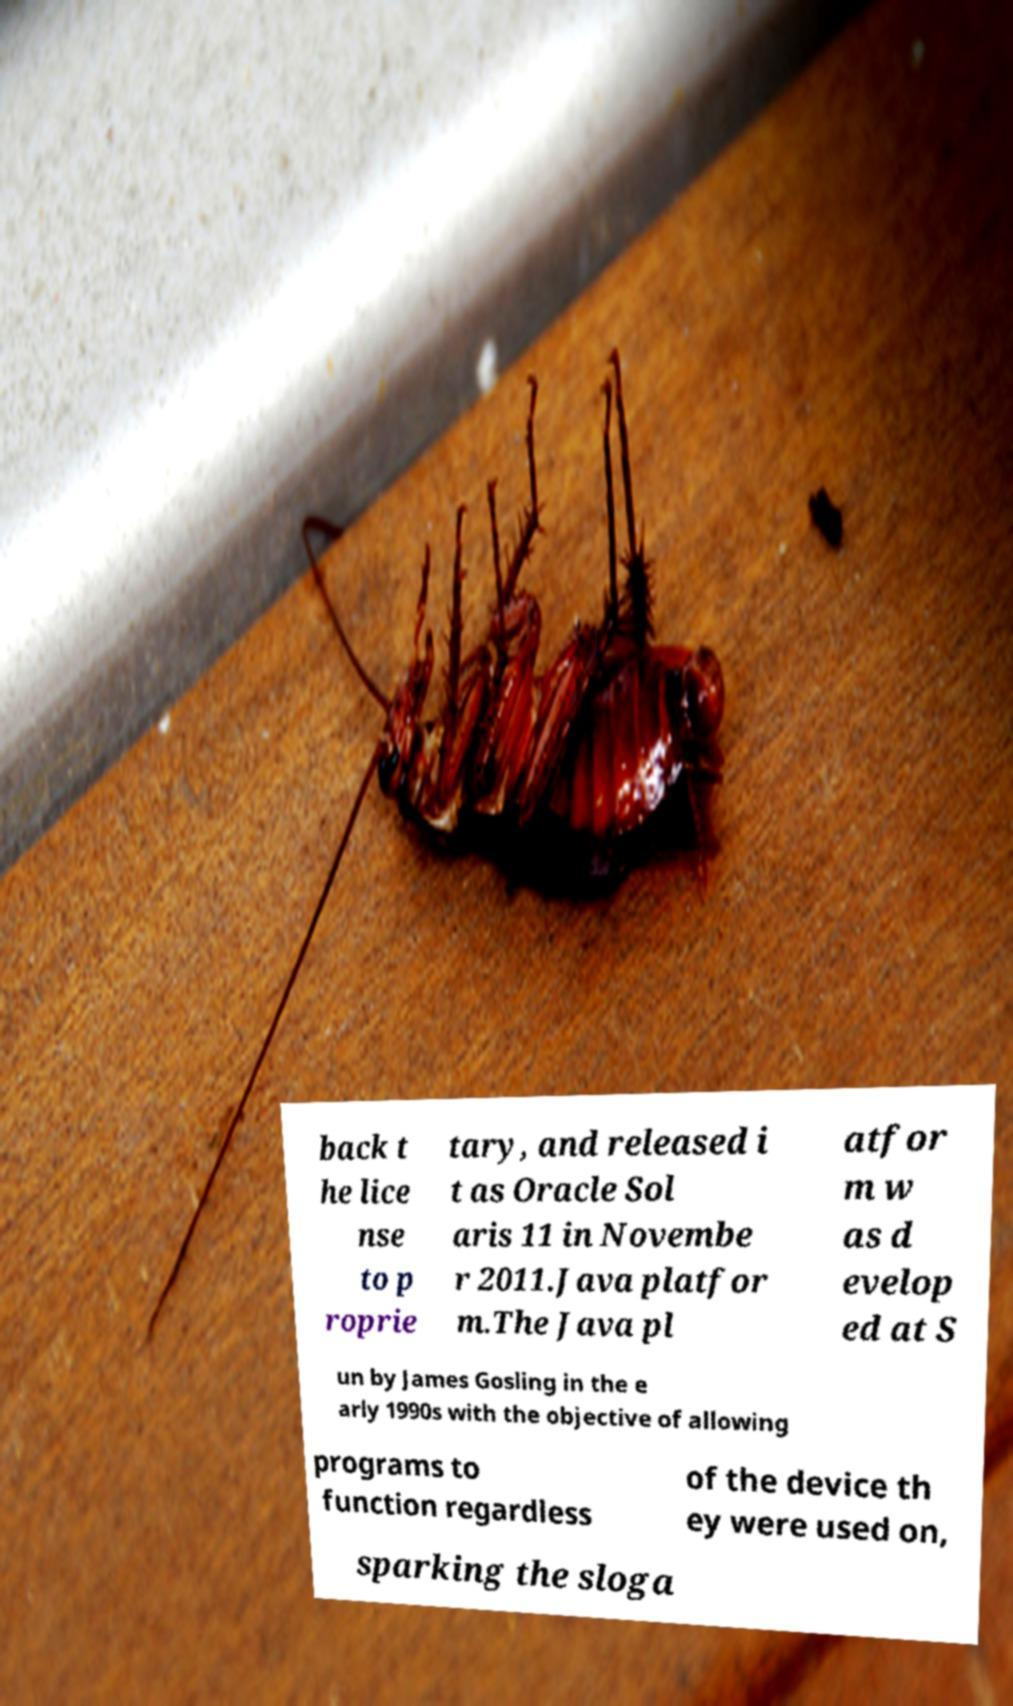Could you extract and type out the text from this image? back t he lice nse to p roprie tary, and released i t as Oracle Sol aris 11 in Novembe r 2011.Java platfor m.The Java pl atfor m w as d evelop ed at S un by James Gosling in the e arly 1990s with the objective of allowing programs to function regardless of the device th ey were used on, sparking the sloga 